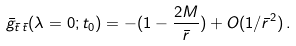<formula> <loc_0><loc_0><loc_500><loc_500>\bar { g } _ { \bar { t } \, \bar { t } } ( \lambda = 0 ; t _ { 0 } ) = - ( 1 - \frac { 2 M } { \bar { r } } ) + O ( 1 / \bar { r } ^ { 2 } ) \, .</formula> 